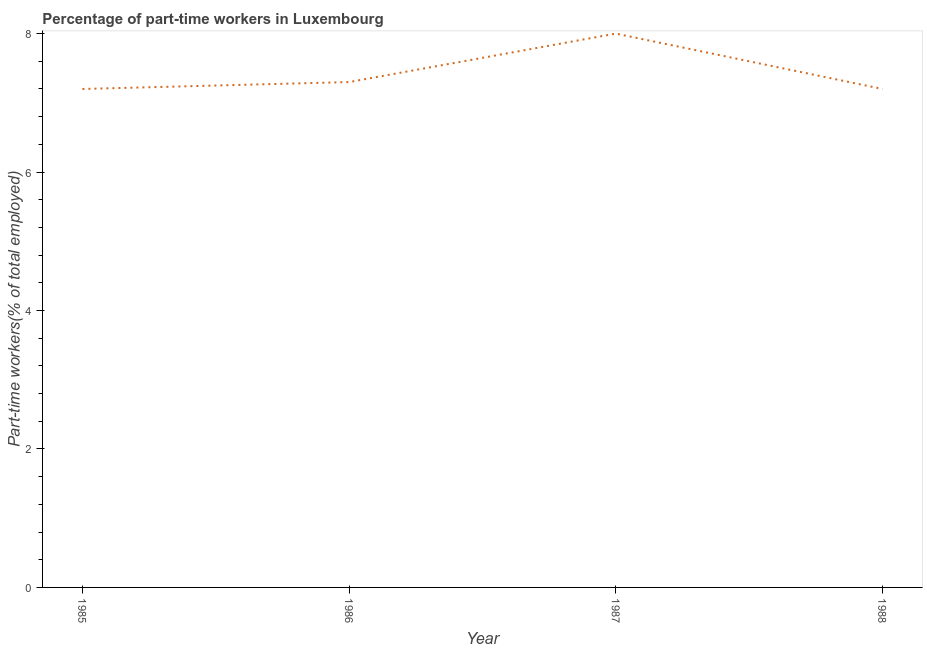Across all years, what is the minimum percentage of part-time workers?
Provide a succinct answer. 7.2. In which year was the percentage of part-time workers minimum?
Make the answer very short. 1985. What is the sum of the percentage of part-time workers?
Your response must be concise. 29.7. What is the average percentage of part-time workers per year?
Your answer should be compact. 7.42. What is the median percentage of part-time workers?
Your answer should be compact. 7.25. What is the ratio of the percentage of part-time workers in 1985 to that in 1986?
Provide a short and direct response. 0.99. What is the difference between the highest and the second highest percentage of part-time workers?
Your response must be concise. 0.7. What is the difference between the highest and the lowest percentage of part-time workers?
Your answer should be very brief. 0.8. How many lines are there?
Your answer should be compact. 1. What is the title of the graph?
Provide a succinct answer. Percentage of part-time workers in Luxembourg. What is the label or title of the Y-axis?
Keep it short and to the point. Part-time workers(% of total employed). What is the Part-time workers(% of total employed) of 1985?
Keep it short and to the point. 7.2. What is the Part-time workers(% of total employed) of 1986?
Give a very brief answer. 7.3. What is the Part-time workers(% of total employed) of 1987?
Offer a terse response. 8. What is the Part-time workers(% of total employed) in 1988?
Ensure brevity in your answer.  7.2. What is the difference between the Part-time workers(% of total employed) in 1986 and 1988?
Ensure brevity in your answer.  0.1. What is the ratio of the Part-time workers(% of total employed) in 1985 to that in 1988?
Give a very brief answer. 1. What is the ratio of the Part-time workers(% of total employed) in 1986 to that in 1988?
Offer a terse response. 1.01. What is the ratio of the Part-time workers(% of total employed) in 1987 to that in 1988?
Your response must be concise. 1.11. 